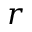<formula> <loc_0><loc_0><loc_500><loc_500>r</formula> 